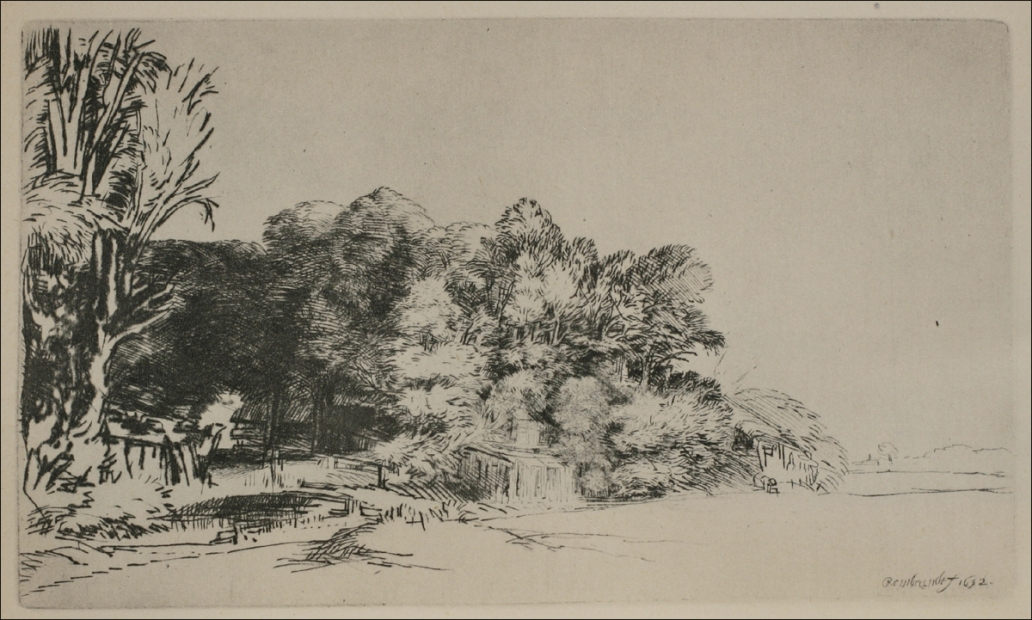Can you identify the time period or art movement this etching might belong to? While I cannot definitively determine the time period or art movement from the image alone, the etching style is reminiscent of works from the late 19th to early 20th century, a time when landscape etching experienced a resurgence. It has characteristics that might align with the naturalism movement, where artists aimed to depict their subjects with a high degree of accuracy and detail. The absence of modern elements suggests a pre-contemporary setting, possibly before the industrial landscape began to dramatically alter rural environments. 